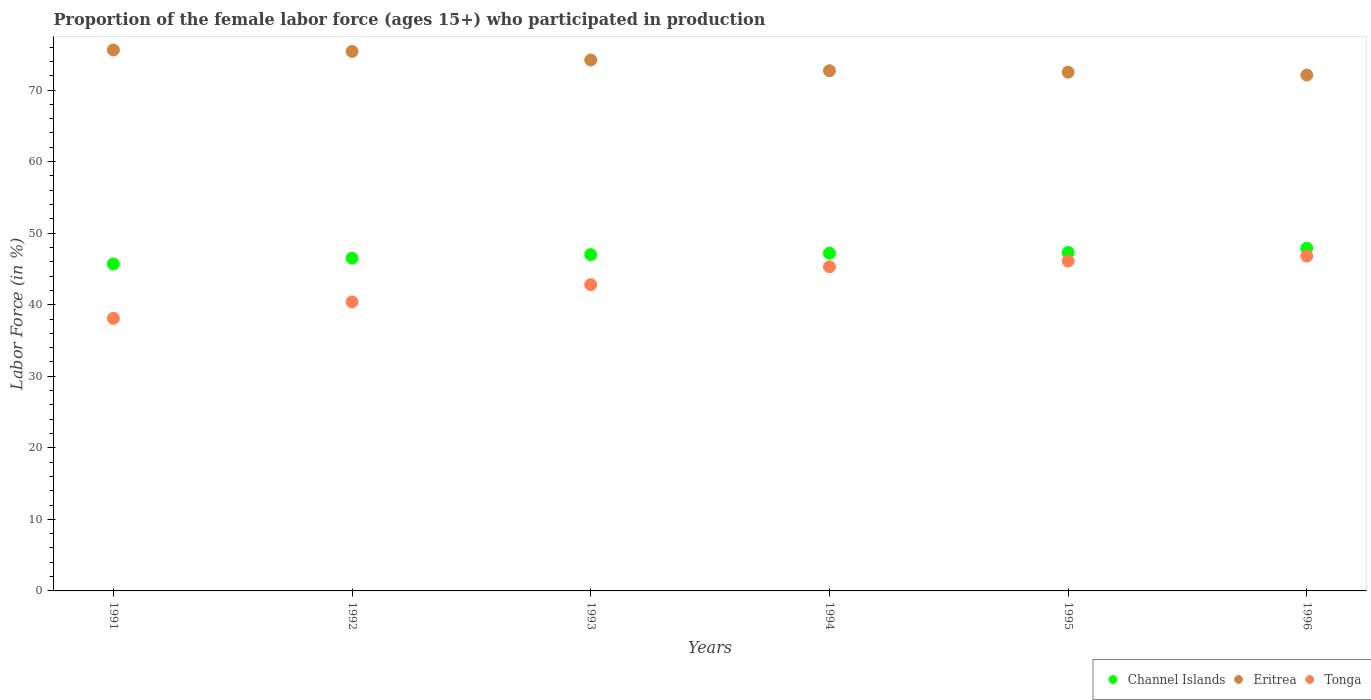Is the number of dotlines equal to the number of legend labels?
Your response must be concise. Yes. What is the proportion of the female labor force who participated in production in Tonga in 1991?
Offer a very short reply. 38.1. Across all years, what is the maximum proportion of the female labor force who participated in production in Channel Islands?
Your answer should be compact. 47.9. Across all years, what is the minimum proportion of the female labor force who participated in production in Channel Islands?
Your answer should be compact. 45.7. In which year was the proportion of the female labor force who participated in production in Tonga minimum?
Make the answer very short. 1991. What is the total proportion of the female labor force who participated in production in Channel Islands in the graph?
Your answer should be compact. 281.6. What is the difference between the proportion of the female labor force who participated in production in Eritrea in 1992 and that in 1996?
Keep it short and to the point. 3.3. What is the difference between the proportion of the female labor force who participated in production in Tonga in 1994 and the proportion of the female labor force who participated in production in Eritrea in 1992?
Ensure brevity in your answer.  -30.1. What is the average proportion of the female labor force who participated in production in Tonga per year?
Offer a terse response. 43.25. In the year 1991, what is the difference between the proportion of the female labor force who participated in production in Eritrea and proportion of the female labor force who participated in production in Tonga?
Your answer should be very brief. 37.5. In how many years, is the proportion of the female labor force who participated in production in Channel Islands greater than 44 %?
Your answer should be compact. 6. What is the ratio of the proportion of the female labor force who participated in production in Tonga in 1993 to that in 1994?
Provide a succinct answer. 0.94. Is the difference between the proportion of the female labor force who participated in production in Eritrea in 1991 and 1993 greater than the difference between the proportion of the female labor force who participated in production in Tonga in 1991 and 1993?
Ensure brevity in your answer.  Yes. What is the difference between the highest and the second highest proportion of the female labor force who participated in production in Eritrea?
Offer a terse response. 0.2. What is the difference between the highest and the lowest proportion of the female labor force who participated in production in Eritrea?
Give a very brief answer. 3.5. Is the sum of the proportion of the female labor force who participated in production in Tonga in 1991 and 1994 greater than the maximum proportion of the female labor force who participated in production in Channel Islands across all years?
Ensure brevity in your answer.  Yes. Does the proportion of the female labor force who participated in production in Eritrea monotonically increase over the years?
Ensure brevity in your answer.  No. Is the proportion of the female labor force who participated in production in Channel Islands strictly less than the proportion of the female labor force who participated in production in Tonga over the years?
Keep it short and to the point. No. How many dotlines are there?
Keep it short and to the point. 3. What is the difference between two consecutive major ticks on the Y-axis?
Make the answer very short. 10. Are the values on the major ticks of Y-axis written in scientific E-notation?
Provide a short and direct response. No. Does the graph contain any zero values?
Offer a very short reply. No. Where does the legend appear in the graph?
Keep it short and to the point. Bottom right. How many legend labels are there?
Provide a succinct answer. 3. What is the title of the graph?
Make the answer very short. Proportion of the female labor force (ages 15+) who participated in production. Does "Tajikistan" appear as one of the legend labels in the graph?
Offer a terse response. No. What is the Labor Force (in %) of Channel Islands in 1991?
Provide a short and direct response. 45.7. What is the Labor Force (in %) of Eritrea in 1991?
Provide a short and direct response. 75.6. What is the Labor Force (in %) of Tonga in 1991?
Provide a short and direct response. 38.1. What is the Labor Force (in %) in Channel Islands in 1992?
Your answer should be very brief. 46.5. What is the Labor Force (in %) in Eritrea in 1992?
Ensure brevity in your answer.  75.4. What is the Labor Force (in %) of Tonga in 1992?
Make the answer very short. 40.4. What is the Labor Force (in %) in Channel Islands in 1993?
Make the answer very short. 47. What is the Labor Force (in %) of Eritrea in 1993?
Give a very brief answer. 74.2. What is the Labor Force (in %) in Tonga in 1993?
Keep it short and to the point. 42.8. What is the Labor Force (in %) of Channel Islands in 1994?
Give a very brief answer. 47.2. What is the Labor Force (in %) of Eritrea in 1994?
Your answer should be very brief. 72.7. What is the Labor Force (in %) in Tonga in 1994?
Give a very brief answer. 45.3. What is the Labor Force (in %) in Channel Islands in 1995?
Ensure brevity in your answer.  47.3. What is the Labor Force (in %) of Eritrea in 1995?
Your response must be concise. 72.5. What is the Labor Force (in %) in Tonga in 1995?
Give a very brief answer. 46.1. What is the Labor Force (in %) in Channel Islands in 1996?
Your answer should be compact. 47.9. What is the Labor Force (in %) in Eritrea in 1996?
Make the answer very short. 72.1. What is the Labor Force (in %) in Tonga in 1996?
Make the answer very short. 46.8. Across all years, what is the maximum Labor Force (in %) in Channel Islands?
Offer a very short reply. 47.9. Across all years, what is the maximum Labor Force (in %) of Eritrea?
Provide a short and direct response. 75.6. Across all years, what is the maximum Labor Force (in %) of Tonga?
Keep it short and to the point. 46.8. Across all years, what is the minimum Labor Force (in %) in Channel Islands?
Offer a terse response. 45.7. Across all years, what is the minimum Labor Force (in %) of Eritrea?
Your answer should be very brief. 72.1. Across all years, what is the minimum Labor Force (in %) of Tonga?
Give a very brief answer. 38.1. What is the total Labor Force (in %) in Channel Islands in the graph?
Ensure brevity in your answer.  281.6. What is the total Labor Force (in %) in Eritrea in the graph?
Offer a terse response. 442.5. What is the total Labor Force (in %) of Tonga in the graph?
Your answer should be compact. 259.5. What is the difference between the Labor Force (in %) of Channel Islands in 1991 and that in 1992?
Provide a short and direct response. -0.8. What is the difference between the Labor Force (in %) of Eritrea in 1991 and that in 1992?
Offer a very short reply. 0.2. What is the difference between the Labor Force (in %) in Eritrea in 1991 and that in 1993?
Provide a succinct answer. 1.4. What is the difference between the Labor Force (in %) of Channel Islands in 1991 and that in 1994?
Provide a short and direct response. -1.5. What is the difference between the Labor Force (in %) of Tonga in 1991 and that in 1994?
Provide a succinct answer. -7.2. What is the difference between the Labor Force (in %) in Channel Islands in 1991 and that in 1995?
Ensure brevity in your answer.  -1.6. What is the difference between the Labor Force (in %) in Eritrea in 1991 and that in 1995?
Your answer should be compact. 3.1. What is the difference between the Labor Force (in %) of Eritrea in 1991 and that in 1996?
Make the answer very short. 3.5. What is the difference between the Labor Force (in %) of Channel Islands in 1992 and that in 1993?
Keep it short and to the point. -0.5. What is the difference between the Labor Force (in %) in Tonga in 1992 and that in 1994?
Your answer should be compact. -4.9. What is the difference between the Labor Force (in %) in Channel Islands in 1992 and that in 1995?
Your answer should be very brief. -0.8. What is the difference between the Labor Force (in %) in Channel Islands in 1992 and that in 1996?
Give a very brief answer. -1.4. What is the difference between the Labor Force (in %) in Tonga in 1992 and that in 1996?
Offer a terse response. -6.4. What is the difference between the Labor Force (in %) of Channel Islands in 1993 and that in 1994?
Give a very brief answer. -0.2. What is the difference between the Labor Force (in %) of Eritrea in 1993 and that in 1994?
Keep it short and to the point. 1.5. What is the difference between the Labor Force (in %) of Channel Islands in 1993 and that in 1995?
Provide a succinct answer. -0.3. What is the difference between the Labor Force (in %) of Tonga in 1993 and that in 1995?
Ensure brevity in your answer.  -3.3. What is the difference between the Labor Force (in %) in Channel Islands in 1993 and that in 1996?
Provide a short and direct response. -0.9. What is the difference between the Labor Force (in %) of Eritrea in 1993 and that in 1996?
Offer a very short reply. 2.1. What is the difference between the Labor Force (in %) of Channel Islands in 1994 and that in 1995?
Ensure brevity in your answer.  -0.1. What is the difference between the Labor Force (in %) in Eritrea in 1994 and that in 1995?
Provide a succinct answer. 0.2. What is the difference between the Labor Force (in %) in Tonga in 1994 and that in 1995?
Your response must be concise. -0.8. What is the difference between the Labor Force (in %) in Channel Islands in 1994 and that in 1996?
Ensure brevity in your answer.  -0.7. What is the difference between the Labor Force (in %) in Channel Islands in 1995 and that in 1996?
Your answer should be very brief. -0.6. What is the difference between the Labor Force (in %) of Tonga in 1995 and that in 1996?
Make the answer very short. -0.7. What is the difference between the Labor Force (in %) of Channel Islands in 1991 and the Labor Force (in %) of Eritrea in 1992?
Offer a very short reply. -29.7. What is the difference between the Labor Force (in %) in Eritrea in 1991 and the Labor Force (in %) in Tonga in 1992?
Make the answer very short. 35.2. What is the difference between the Labor Force (in %) of Channel Islands in 1991 and the Labor Force (in %) of Eritrea in 1993?
Make the answer very short. -28.5. What is the difference between the Labor Force (in %) of Channel Islands in 1991 and the Labor Force (in %) of Tonga in 1993?
Provide a succinct answer. 2.9. What is the difference between the Labor Force (in %) in Eritrea in 1991 and the Labor Force (in %) in Tonga in 1993?
Ensure brevity in your answer.  32.8. What is the difference between the Labor Force (in %) in Channel Islands in 1991 and the Labor Force (in %) in Eritrea in 1994?
Offer a terse response. -27. What is the difference between the Labor Force (in %) of Eritrea in 1991 and the Labor Force (in %) of Tonga in 1994?
Keep it short and to the point. 30.3. What is the difference between the Labor Force (in %) in Channel Islands in 1991 and the Labor Force (in %) in Eritrea in 1995?
Provide a succinct answer. -26.8. What is the difference between the Labor Force (in %) of Eritrea in 1991 and the Labor Force (in %) of Tonga in 1995?
Your response must be concise. 29.5. What is the difference between the Labor Force (in %) in Channel Islands in 1991 and the Labor Force (in %) in Eritrea in 1996?
Offer a very short reply. -26.4. What is the difference between the Labor Force (in %) in Channel Islands in 1991 and the Labor Force (in %) in Tonga in 1996?
Provide a short and direct response. -1.1. What is the difference between the Labor Force (in %) of Eritrea in 1991 and the Labor Force (in %) of Tonga in 1996?
Your answer should be very brief. 28.8. What is the difference between the Labor Force (in %) of Channel Islands in 1992 and the Labor Force (in %) of Eritrea in 1993?
Your answer should be very brief. -27.7. What is the difference between the Labor Force (in %) of Eritrea in 1992 and the Labor Force (in %) of Tonga in 1993?
Provide a short and direct response. 32.6. What is the difference between the Labor Force (in %) of Channel Islands in 1992 and the Labor Force (in %) of Eritrea in 1994?
Provide a succinct answer. -26.2. What is the difference between the Labor Force (in %) in Channel Islands in 1992 and the Labor Force (in %) in Tonga in 1994?
Your answer should be very brief. 1.2. What is the difference between the Labor Force (in %) in Eritrea in 1992 and the Labor Force (in %) in Tonga in 1994?
Ensure brevity in your answer.  30.1. What is the difference between the Labor Force (in %) of Channel Islands in 1992 and the Labor Force (in %) of Eritrea in 1995?
Your answer should be compact. -26. What is the difference between the Labor Force (in %) of Eritrea in 1992 and the Labor Force (in %) of Tonga in 1995?
Give a very brief answer. 29.3. What is the difference between the Labor Force (in %) of Channel Islands in 1992 and the Labor Force (in %) of Eritrea in 1996?
Provide a short and direct response. -25.6. What is the difference between the Labor Force (in %) of Eritrea in 1992 and the Labor Force (in %) of Tonga in 1996?
Your response must be concise. 28.6. What is the difference between the Labor Force (in %) of Channel Islands in 1993 and the Labor Force (in %) of Eritrea in 1994?
Your response must be concise. -25.7. What is the difference between the Labor Force (in %) of Channel Islands in 1993 and the Labor Force (in %) of Tonga in 1994?
Offer a terse response. 1.7. What is the difference between the Labor Force (in %) in Eritrea in 1993 and the Labor Force (in %) in Tonga in 1994?
Offer a very short reply. 28.9. What is the difference between the Labor Force (in %) in Channel Islands in 1993 and the Labor Force (in %) in Eritrea in 1995?
Give a very brief answer. -25.5. What is the difference between the Labor Force (in %) in Channel Islands in 1993 and the Labor Force (in %) in Tonga in 1995?
Provide a short and direct response. 0.9. What is the difference between the Labor Force (in %) in Eritrea in 1993 and the Labor Force (in %) in Tonga in 1995?
Provide a short and direct response. 28.1. What is the difference between the Labor Force (in %) of Channel Islands in 1993 and the Labor Force (in %) of Eritrea in 1996?
Make the answer very short. -25.1. What is the difference between the Labor Force (in %) in Channel Islands in 1993 and the Labor Force (in %) in Tonga in 1996?
Offer a terse response. 0.2. What is the difference between the Labor Force (in %) in Eritrea in 1993 and the Labor Force (in %) in Tonga in 1996?
Give a very brief answer. 27.4. What is the difference between the Labor Force (in %) of Channel Islands in 1994 and the Labor Force (in %) of Eritrea in 1995?
Your answer should be very brief. -25.3. What is the difference between the Labor Force (in %) of Channel Islands in 1994 and the Labor Force (in %) of Tonga in 1995?
Keep it short and to the point. 1.1. What is the difference between the Labor Force (in %) in Eritrea in 1994 and the Labor Force (in %) in Tonga in 1995?
Your answer should be compact. 26.6. What is the difference between the Labor Force (in %) of Channel Islands in 1994 and the Labor Force (in %) of Eritrea in 1996?
Give a very brief answer. -24.9. What is the difference between the Labor Force (in %) of Eritrea in 1994 and the Labor Force (in %) of Tonga in 1996?
Offer a terse response. 25.9. What is the difference between the Labor Force (in %) in Channel Islands in 1995 and the Labor Force (in %) in Eritrea in 1996?
Offer a very short reply. -24.8. What is the difference between the Labor Force (in %) of Channel Islands in 1995 and the Labor Force (in %) of Tonga in 1996?
Provide a short and direct response. 0.5. What is the difference between the Labor Force (in %) in Eritrea in 1995 and the Labor Force (in %) in Tonga in 1996?
Ensure brevity in your answer.  25.7. What is the average Labor Force (in %) of Channel Islands per year?
Make the answer very short. 46.93. What is the average Labor Force (in %) in Eritrea per year?
Give a very brief answer. 73.75. What is the average Labor Force (in %) in Tonga per year?
Your response must be concise. 43.25. In the year 1991, what is the difference between the Labor Force (in %) in Channel Islands and Labor Force (in %) in Eritrea?
Your response must be concise. -29.9. In the year 1991, what is the difference between the Labor Force (in %) of Eritrea and Labor Force (in %) of Tonga?
Provide a succinct answer. 37.5. In the year 1992, what is the difference between the Labor Force (in %) in Channel Islands and Labor Force (in %) in Eritrea?
Provide a short and direct response. -28.9. In the year 1992, what is the difference between the Labor Force (in %) in Channel Islands and Labor Force (in %) in Tonga?
Keep it short and to the point. 6.1. In the year 1993, what is the difference between the Labor Force (in %) of Channel Islands and Labor Force (in %) of Eritrea?
Keep it short and to the point. -27.2. In the year 1993, what is the difference between the Labor Force (in %) of Channel Islands and Labor Force (in %) of Tonga?
Keep it short and to the point. 4.2. In the year 1993, what is the difference between the Labor Force (in %) of Eritrea and Labor Force (in %) of Tonga?
Give a very brief answer. 31.4. In the year 1994, what is the difference between the Labor Force (in %) of Channel Islands and Labor Force (in %) of Eritrea?
Your answer should be very brief. -25.5. In the year 1994, what is the difference between the Labor Force (in %) of Channel Islands and Labor Force (in %) of Tonga?
Offer a terse response. 1.9. In the year 1994, what is the difference between the Labor Force (in %) of Eritrea and Labor Force (in %) of Tonga?
Give a very brief answer. 27.4. In the year 1995, what is the difference between the Labor Force (in %) in Channel Islands and Labor Force (in %) in Eritrea?
Keep it short and to the point. -25.2. In the year 1995, what is the difference between the Labor Force (in %) of Eritrea and Labor Force (in %) of Tonga?
Offer a terse response. 26.4. In the year 1996, what is the difference between the Labor Force (in %) in Channel Islands and Labor Force (in %) in Eritrea?
Offer a very short reply. -24.2. In the year 1996, what is the difference between the Labor Force (in %) of Channel Islands and Labor Force (in %) of Tonga?
Make the answer very short. 1.1. In the year 1996, what is the difference between the Labor Force (in %) in Eritrea and Labor Force (in %) in Tonga?
Offer a terse response. 25.3. What is the ratio of the Labor Force (in %) of Channel Islands in 1991 to that in 1992?
Your answer should be very brief. 0.98. What is the ratio of the Labor Force (in %) in Tonga in 1991 to that in 1992?
Offer a very short reply. 0.94. What is the ratio of the Labor Force (in %) in Channel Islands in 1991 to that in 1993?
Provide a succinct answer. 0.97. What is the ratio of the Labor Force (in %) of Eritrea in 1991 to that in 1993?
Your answer should be compact. 1.02. What is the ratio of the Labor Force (in %) of Tonga in 1991 to that in 1993?
Give a very brief answer. 0.89. What is the ratio of the Labor Force (in %) in Channel Islands in 1991 to that in 1994?
Offer a terse response. 0.97. What is the ratio of the Labor Force (in %) in Eritrea in 1991 to that in 1994?
Offer a very short reply. 1.04. What is the ratio of the Labor Force (in %) of Tonga in 1991 to that in 1994?
Give a very brief answer. 0.84. What is the ratio of the Labor Force (in %) in Channel Islands in 1991 to that in 1995?
Your answer should be very brief. 0.97. What is the ratio of the Labor Force (in %) in Eritrea in 1991 to that in 1995?
Ensure brevity in your answer.  1.04. What is the ratio of the Labor Force (in %) in Tonga in 1991 to that in 1995?
Keep it short and to the point. 0.83. What is the ratio of the Labor Force (in %) in Channel Islands in 1991 to that in 1996?
Offer a terse response. 0.95. What is the ratio of the Labor Force (in %) in Eritrea in 1991 to that in 1996?
Keep it short and to the point. 1.05. What is the ratio of the Labor Force (in %) of Tonga in 1991 to that in 1996?
Your answer should be compact. 0.81. What is the ratio of the Labor Force (in %) in Eritrea in 1992 to that in 1993?
Provide a succinct answer. 1.02. What is the ratio of the Labor Force (in %) in Tonga in 1992 to that in 1993?
Make the answer very short. 0.94. What is the ratio of the Labor Force (in %) of Channel Islands in 1992 to that in 1994?
Provide a short and direct response. 0.99. What is the ratio of the Labor Force (in %) in Eritrea in 1992 to that in 1994?
Ensure brevity in your answer.  1.04. What is the ratio of the Labor Force (in %) of Tonga in 1992 to that in 1994?
Give a very brief answer. 0.89. What is the ratio of the Labor Force (in %) in Channel Islands in 1992 to that in 1995?
Provide a short and direct response. 0.98. What is the ratio of the Labor Force (in %) in Tonga in 1992 to that in 1995?
Keep it short and to the point. 0.88. What is the ratio of the Labor Force (in %) of Channel Islands in 1992 to that in 1996?
Offer a terse response. 0.97. What is the ratio of the Labor Force (in %) of Eritrea in 1992 to that in 1996?
Give a very brief answer. 1.05. What is the ratio of the Labor Force (in %) of Tonga in 1992 to that in 1996?
Keep it short and to the point. 0.86. What is the ratio of the Labor Force (in %) in Channel Islands in 1993 to that in 1994?
Provide a short and direct response. 1. What is the ratio of the Labor Force (in %) of Eritrea in 1993 to that in 1994?
Offer a very short reply. 1.02. What is the ratio of the Labor Force (in %) of Tonga in 1993 to that in 1994?
Ensure brevity in your answer.  0.94. What is the ratio of the Labor Force (in %) in Channel Islands in 1993 to that in 1995?
Your answer should be very brief. 0.99. What is the ratio of the Labor Force (in %) in Eritrea in 1993 to that in 1995?
Your response must be concise. 1.02. What is the ratio of the Labor Force (in %) of Tonga in 1993 to that in 1995?
Your answer should be compact. 0.93. What is the ratio of the Labor Force (in %) in Channel Islands in 1993 to that in 1996?
Offer a terse response. 0.98. What is the ratio of the Labor Force (in %) in Eritrea in 1993 to that in 1996?
Your response must be concise. 1.03. What is the ratio of the Labor Force (in %) of Tonga in 1993 to that in 1996?
Provide a short and direct response. 0.91. What is the ratio of the Labor Force (in %) of Tonga in 1994 to that in 1995?
Make the answer very short. 0.98. What is the ratio of the Labor Force (in %) in Channel Islands in 1994 to that in 1996?
Your response must be concise. 0.99. What is the ratio of the Labor Force (in %) in Eritrea in 1994 to that in 1996?
Provide a short and direct response. 1.01. What is the ratio of the Labor Force (in %) of Tonga in 1994 to that in 1996?
Ensure brevity in your answer.  0.97. What is the ratio of the Labor Force (in %) in Channel Islands in 1995 to that in 1996?
Provide a succinct answer. 0.99. What is the ratio of the Labor Force (in %) in Eritrea in 1995 to that in 1996?
Make the answer very short. 1.01. What is the difference between the highest and the second highest Labor Force (in %) in Tonga?
Your response must be concise. 0.7. What is the difference between the highest and the lowest Labor Force (in %) in Eritrea?
Ensure brevity in your answer.  3.5. 